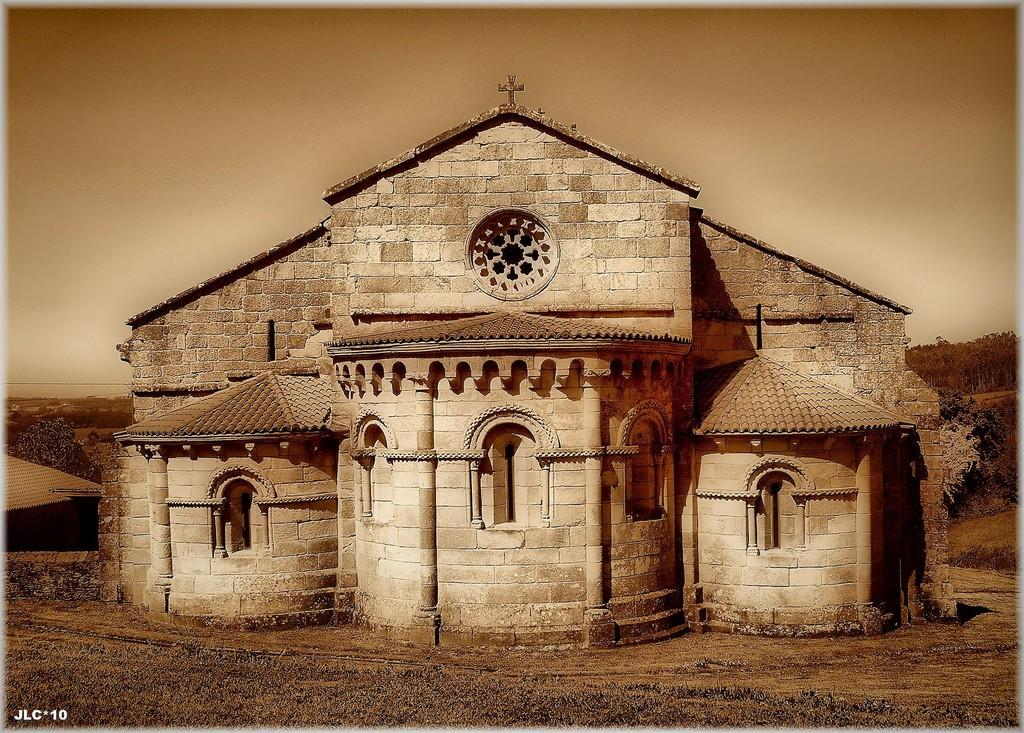What type of structure is present in the image? There is a building in the image. What type of vegetation is visible at the bottom of the image? Grass is visible at the bottom of the image. What can be seen in the background of the image? There are trees in the background of the image. What is visible at the top of the image? The sky is visible at the top of the image. What type of belief is depicted in the image? There is no indication of any belief being depicted in the image; it primarily features a building, grass, trees, and the sky. 